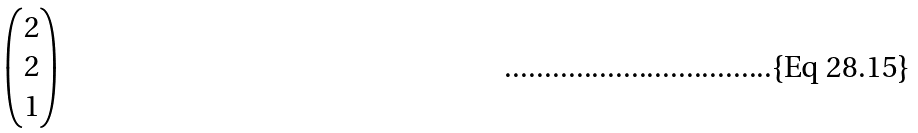Convert formula to latex. <formula><loc_0><loc_0><loc_500><loc_500>\begin{pmatrix} 2 \\ 2 \\ 1 \end{pmatrix}</formula> 